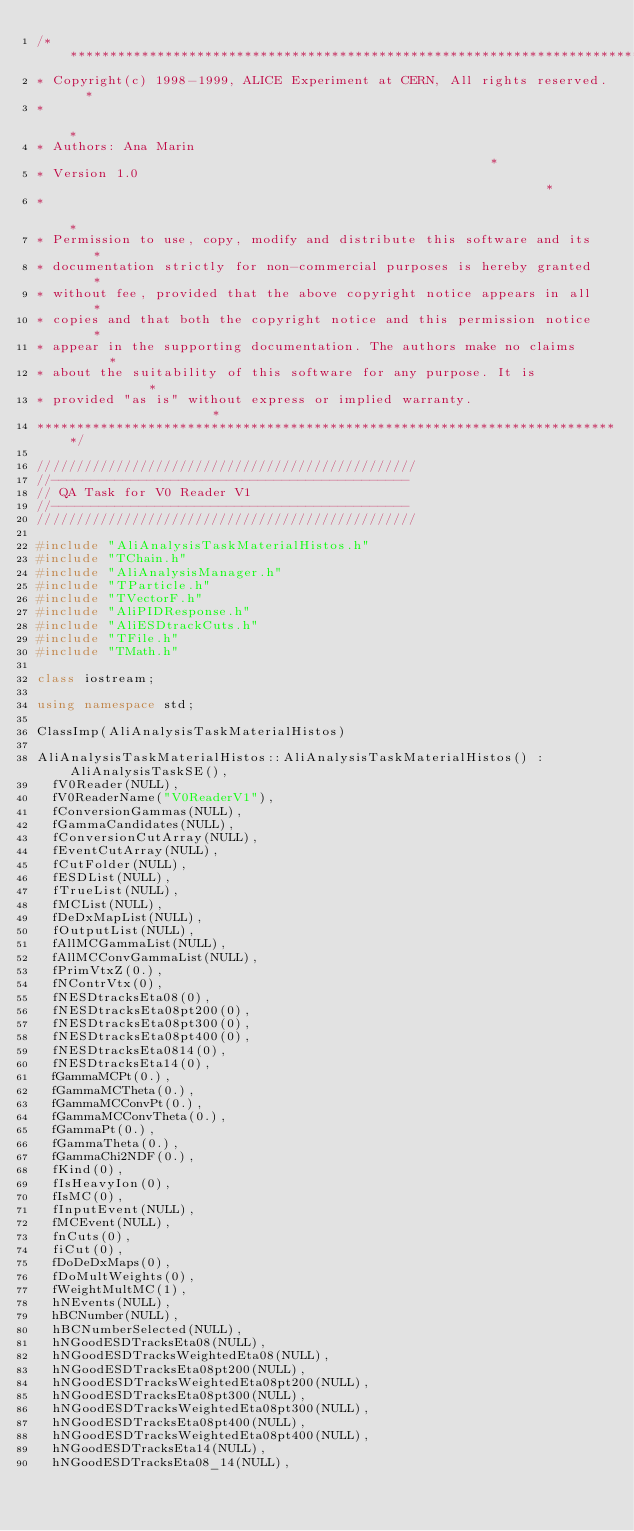<code> <loc_0><loc_0><loc_500><loc_500><_C++_>/**************************************************************************
* Copyright(c) 1998-1999, ALICE Experiment at CERN, All rights reserved.  *
*                                                                         *
* Authors: Ana Marin                                                      *
* Version 1.0                                                             *
*                                                                         *
* Permission to use, copy, modify and distribute this software and its    *
* documentation strictly for non-commercial purposes is hereby granted    *
* without fee, provided that the above copyright notice appears in all    *
* copies and that both the copyright notice and this permission notice    *
* appear in the supporting documentation. The authors make no claims      *
* about the suitability of this software for any purpose. It is           *
* provided "as is" without express or implied warranty.                   *
**************************************************************************/

////////////////////////////////////////////////
//---------------------------------------------
// QA Task for V0 Reader V1
//---------------------------------------------
////////////////////////////////////////////////

#include "AliAnalysisTaskMaterialHistos.h"
#include "TChain.h"
#include "AliAnalysisManager.h"
#include "TParticle.h"
#include "TVectorF.h"
#include "AliPIDResponse.h"
#include "AliESDtrackCuts.h"
#include "TFile.h"
#include "TMath.h"

class iostream;

using namespace std;

ClassImp(AliAnalysisTaskMaterialHistos)

AliAnalysisTaskMaterialHistos::AliAnalysisTaskMaterialHistos() : AliAnalysisTaskSE(),
  fV0Reader(NULL),
  fV0ReaderName("V0ReaderV1"),
  fConversionGammas(NULL),
  fGammaCandidates(NULL),
  fConversionCutArray(NULL),
  fEventCutArray(NULL),
  fCutFolder(NULL),
  fESDList(NULL),
  fTrueList(NULL),
  fMCList(NULL),
  fDeDxMapList(NULL),
  fOutputList(NULL),
  fAllMCGammaList(NULL),
  fAllMCConvGammaList(NULL),
  fPrimVtxZ(0.),
  fNContrVtx(0),
  fNESDtracksEta08(0),
  fNESDtracksEta08pt200(0),
  fNESDtracksEta08pt300(0),
  fNESDtracksEta08pt400(0),
  fNESDtracksEta0814(0),
  fNESDtracksEta14(0),
  fGammaMCPt(0.),
  fGammaMCTheta(0.),
  fGammaMCConvPt(0.),
  fGammaMCConvTheta(0.),
  fGammaPt(0.),
  fGammaTheta(0.),
  fGammaChi2NDF(0.),
  fKind(0),
  fIsHeavyIon(0),
  fIsMC(0),
  fInputEvent(NULL),
  fMCEvent(NULL),
  fnCuts(0),
  fiCut(0),
  fDoDeDxMaps(0),
  fDoMultWeights(0),
  fWeightMultMC(1),
  hNEvents(NULL),
  hBCNumber(NULL),
  hBCNumberSelected(NULL),
  hNGoodESDTracksEta08(NULL),
  hNGoodESDTracksWeightedEta08(NULL),
  hNGoodESDTracksEta08pt200(NULL),
  hNGoodESDTracksWeightedEta08pt200(NULL),
  hNGoodESDTracksEta08pt300(NULL),
  hNGoodESDTracksWeightedEta08pt300(NULL),
  hNGoodESDTracksEta08pt400(NULL),
  hNGoodESDTracksWeightedEta08pt400(NULL),
  hNGoodESDTracksEta14(NULL),
  hNGoodESDTracksEta08_14(NULL),</code> 